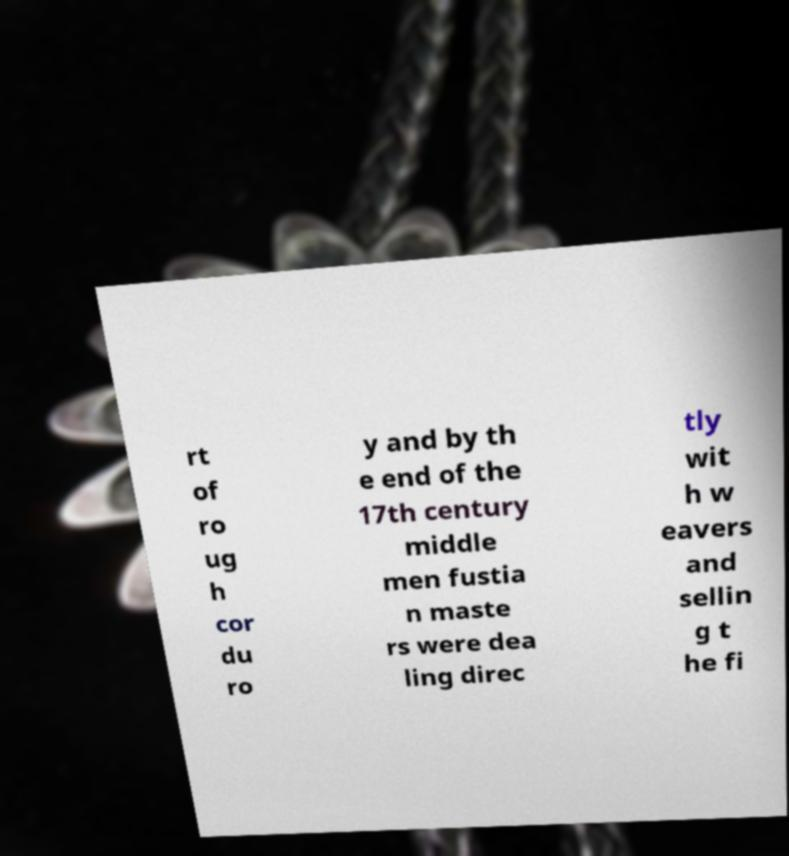I need the written content from this picture converted into text. Can you do that? rt of ro ug h cor du ro y and by th e end of the 17th century middle men fustia n maste rs were dea ling direc tly wit h w eavers and sellin g t he fi 